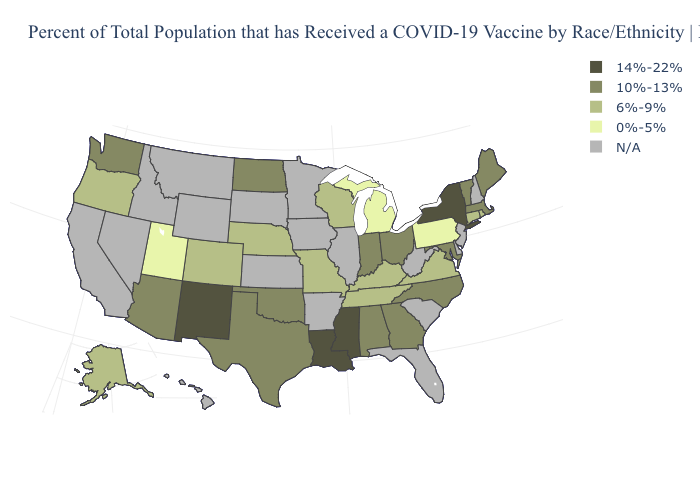What is the lowest value in the West?
Write a very short answer. 0%-5%. Name the states that have a value in the range 0%-5%?
Short answer required. Michigan, Pennsylvania, Utah. Does Utah have the lowest value in the USA?
Answer briefly. Yes. What is the value of Michigan?
Keep it brief. 0%-5%. What is the highest value in states that border Texas?
Short answer required. 14%-22%. Does the map have missing data?
Be succinct. Yes. Name the states that have a value in the range 0%-5%?
Answer briefly. Michigan, Pennsylvania, Utah. Name the states that have a value in the range 10%-13%?
Concise answer only. Alabama, Arizona, Georgia, Indiana, Maine, Maryland, Massachusetts, North Carolina, North Dakota, Ohio, Oklahoma, Texas, Vermont, Washington. Which states have the lowest value in the USA?
Answer briefly. Michigan, Pennsylvania, Utah. What is the value of New Jersey?
Be succinct. N/A. What is the value of Louisiana?
Quick response, please. 14%-22%. How many symbols are there in the legend?
Write a very short answer. 5. Does Michigan have the lowest value in the USA?
Give a very brief answer. Yes. 